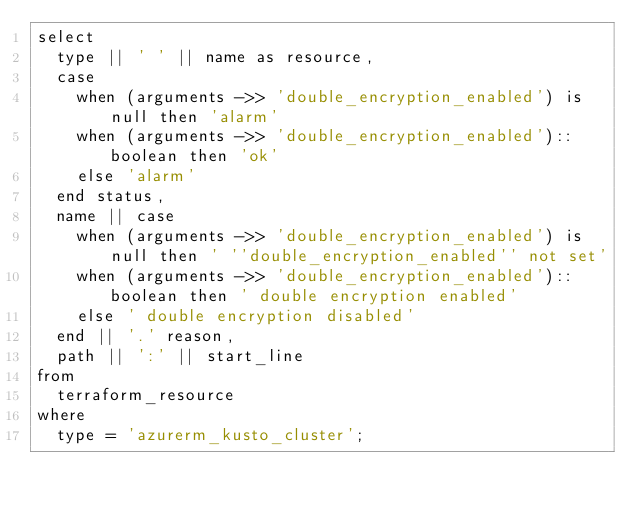Convert code to text. <code><loc_0><loc_0><loc_500><loc_500><_SQL_>select
  type || ' ' || name as resource,
  case
    when (arguments ->> 'double_encryption_enabled') is null then 'alarm'
    when (arguments ->> 'double_encryption_enabled')::boolean then 'ok'
    else 'alarm'
  end status,
  name || case
    when (arguments ->> 'double_encryption_enabled') is null then ' ''double_encryption_enabled'' not set'
    when (arguments ->> 'double_encryption_enabled')::boolean then ' double encryption enabled'
    else ' double encryption disabled'
  end || '.' reason,
  path || ':' || start_line
from
  terraform_resource
where
  type = 'azurerm_kusto_cluster';
</code> 